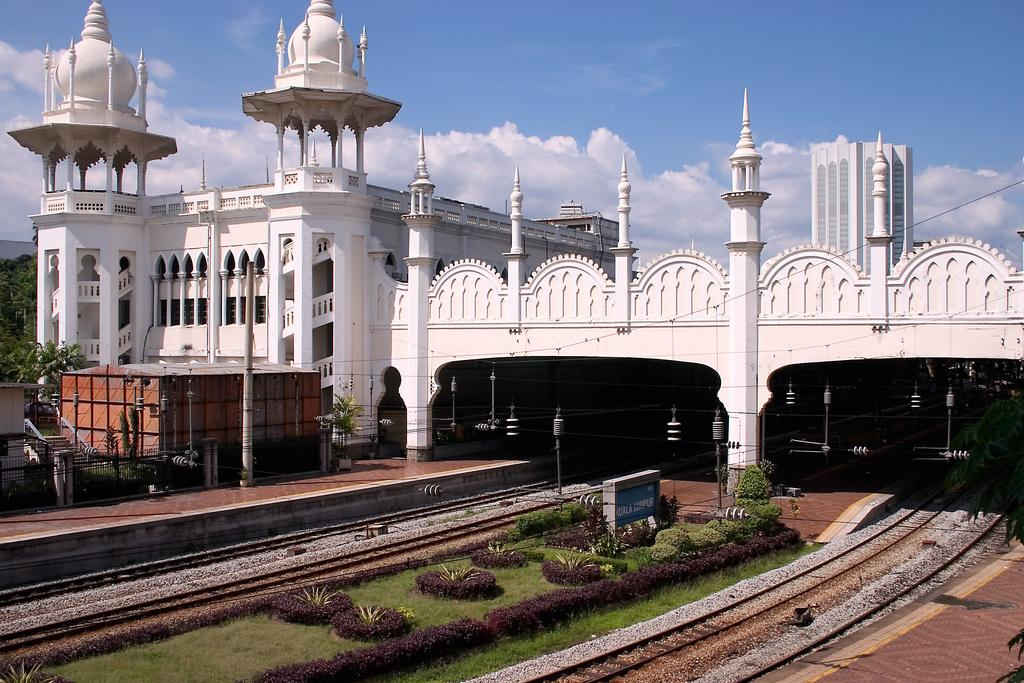What is the color of the building in the image? The building in the image is white in color. What type of vegetation can be seen in the image? There is grass in the image. What type of transportation infrastructure is present in the image? There is a train track in the image. What type of path is visible in the image? There is a footpath in the image. What type of utility infrastructure is present in the image? There are electric wires in the image. What type of barrier is present in the image? There is a fence in the image. What type of vertical structure is present in the image? There is a pole in the image. What type of natural elements can be seen in the image? There are trees in the image. What is the condition of the sky in the image? The sky is cloudy and pale blue in the image. What type of soup is being served in the image? There is no soup present in the image. What is the aftermath of the storm in the image? There is no mention of a storm or its aftermath in the image. 